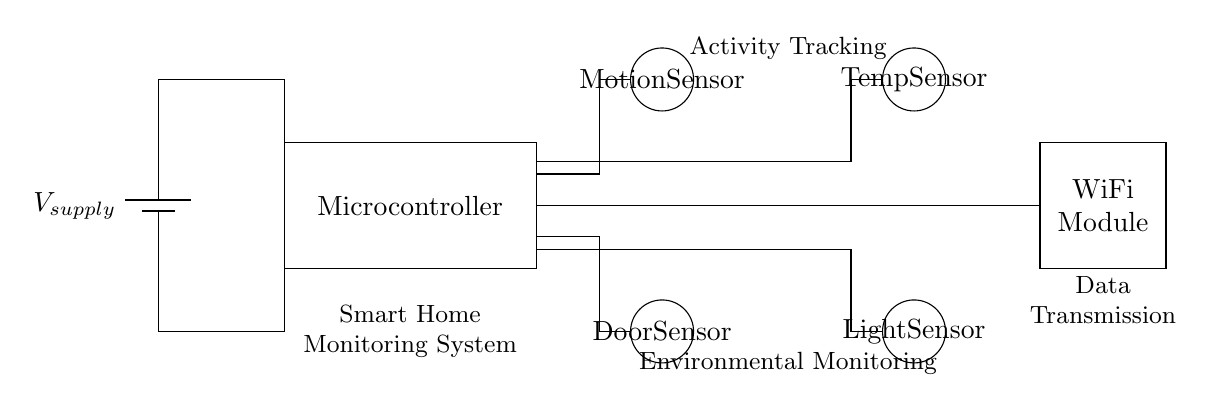What type of sensors are included in this circuit? The circuit includes a motion sensor, door sensor, temperature sensor, and light sensor. These can be identified by their distinct symbols and labels in the diagram.
Answer: motion, door, temperature, light What is the purpose of the microcontroller in this circuit? The microcontroller processes inputs from the various sensors and controls the system's operations, coordinating communication and data processing. This is inferred from its central position and function in similar systems.
Answer: processing inputs What is the role of the WiFi module? The WiFi module is responsible for data transmission, allowing the system to send collected data over the internet for monitoring purposes. Its label directly indicates this function.
Answer: data transmission How many main components are shown in the circuit? The main components include a battery, microcontroller, four sensors, and a WiFi module. By counting each distinct element represented in the diagram, we find there are seven.
Answer: seven Which sensor is likely used for detecting movement? The motion sensor is used to detect movement as indicated by its label and typical function in smart home systems. Its position and designation signify its specific role.
Answer: motion sensor How does the power supply connect to the components? The power supply connects through lines to the microcontroller and then distributes power to the sensors via the microcontroller. This is seen in the circuit's layout where connections lead from the battery to different components.
Answer: through microcontroller 